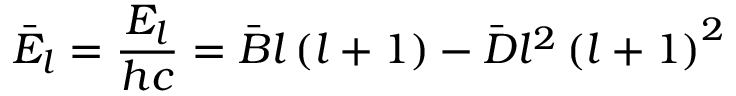Convert formula to latex. <formula><loc_0><loc_0><loc_500><loc_500>{ \bar { E } } _ { l } = { \frac { E _ { l } } { h c } } = { \bar { B } } l \left ( l + 1 \right ) - { \bar { D } } l ^ { 2 } \left ( l + 1 \right ) ^ { 2 }</formula> 